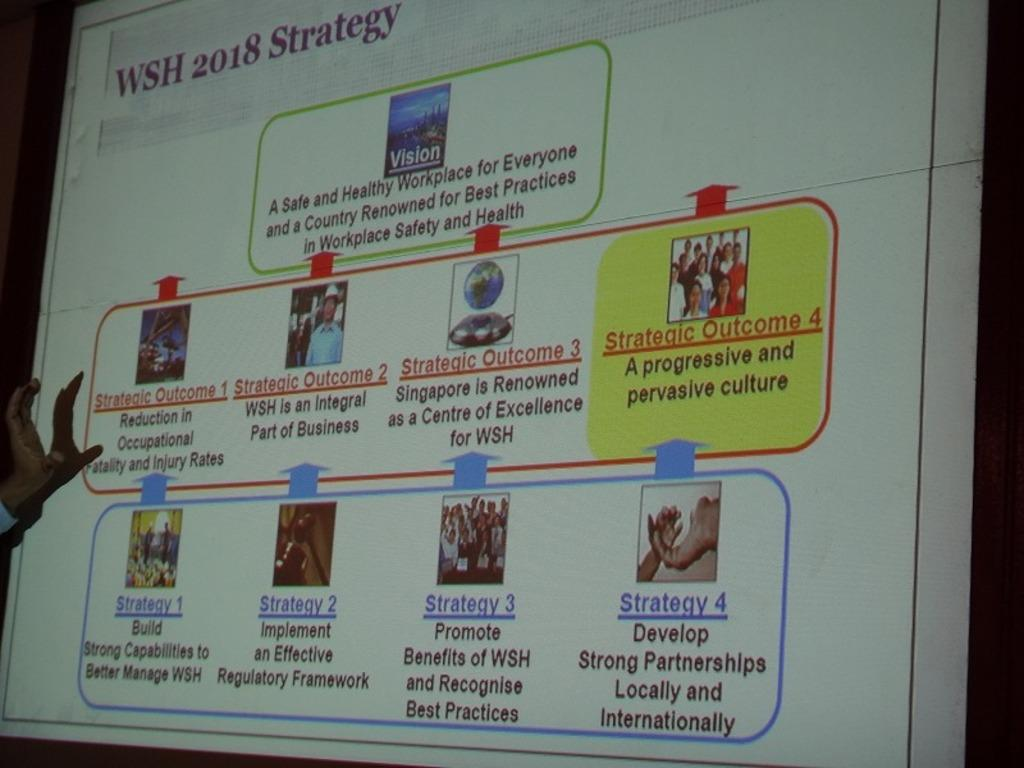<image>
Give a short and clear explanation of the subsequent image. A projector screen shows a presentation called WSH 2018 Strategy. 